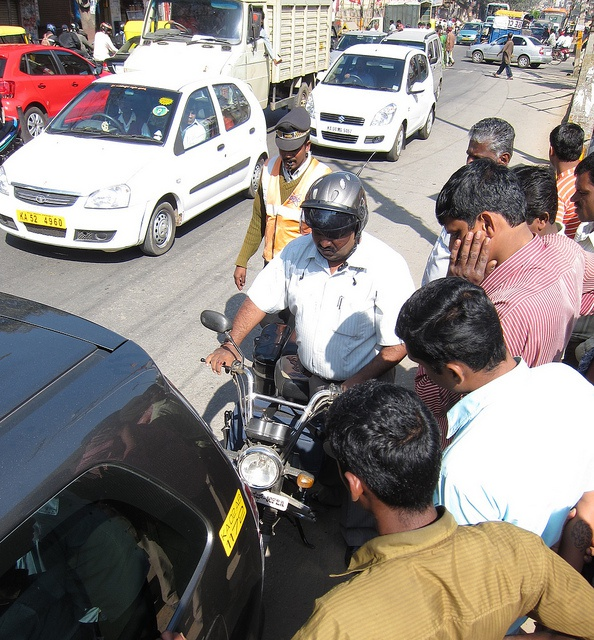Describe the objects in this image and their specific colors. I can see car in black, gray, and blue tones, people in black, tan, and gray tones, car in black, white, gray, and darkgray tones, people in black, white, gray, and brown tones, and people in black, white, and gray tones in this image. 